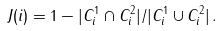Convert formula to latex. <formula><loc_0><loc_0><loc_500><loc_500>J ( i ) = 1 - | C _ { i } ^ { 1 } \cap C _ { i } ^ { 2 } | / | C _ { i } ^ { 1 } \cup C _ { i } ^ { 2 } | \, .</formula> 